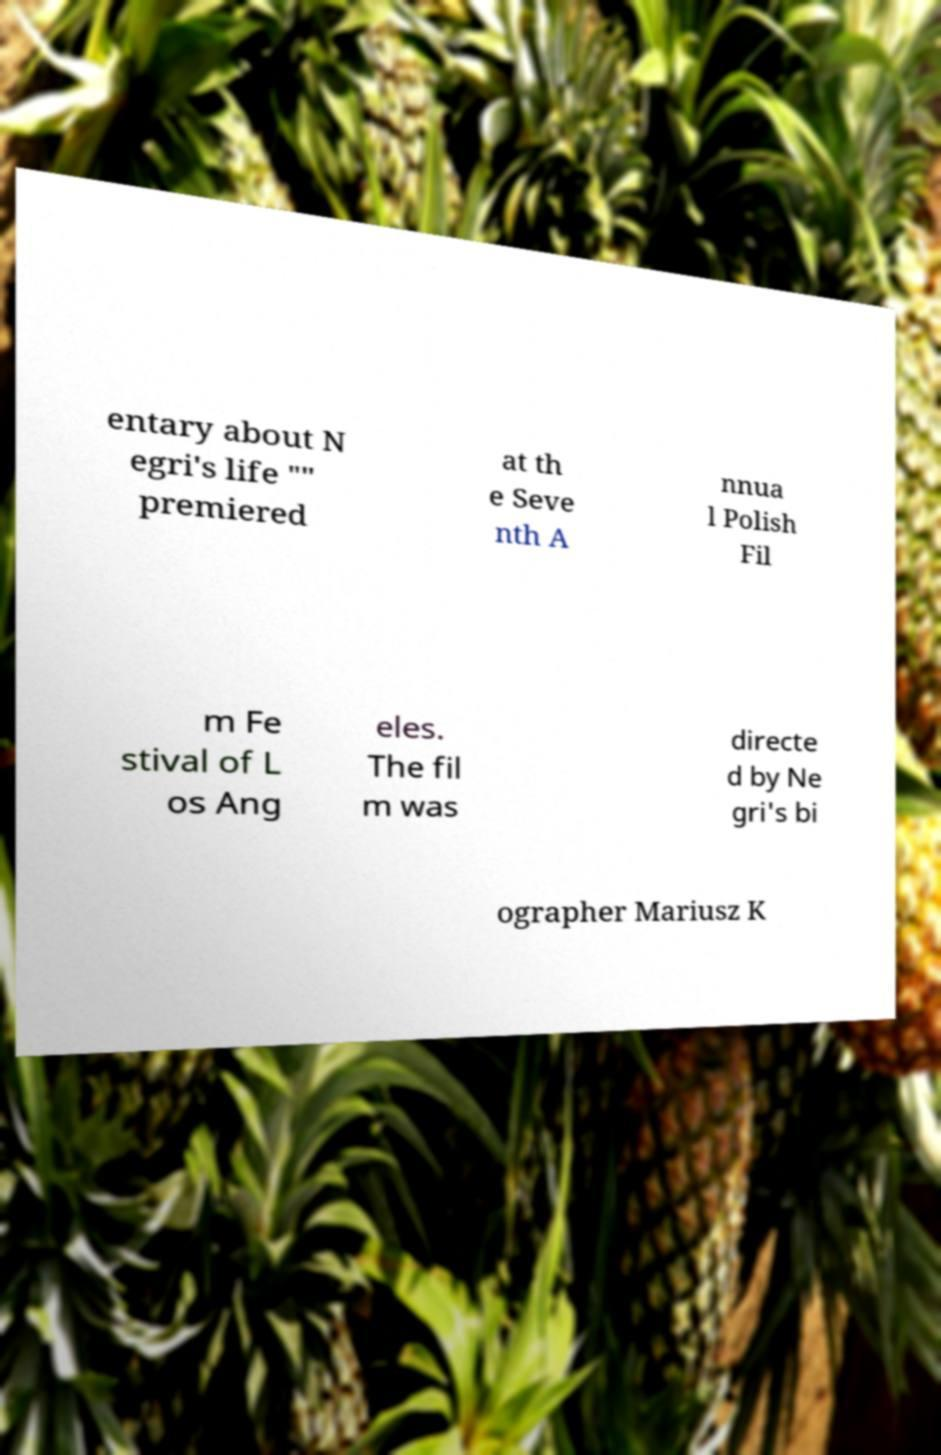For documentation purposes, I need the text within this image transcribed. Could you provide that? entary about N egri's life "" premiered at th e Seve nth A nnua l Polish Fil m Fe stival of L os Ang eles. The fil m was directe d by Ne gri's bi ographer Mariusz K 